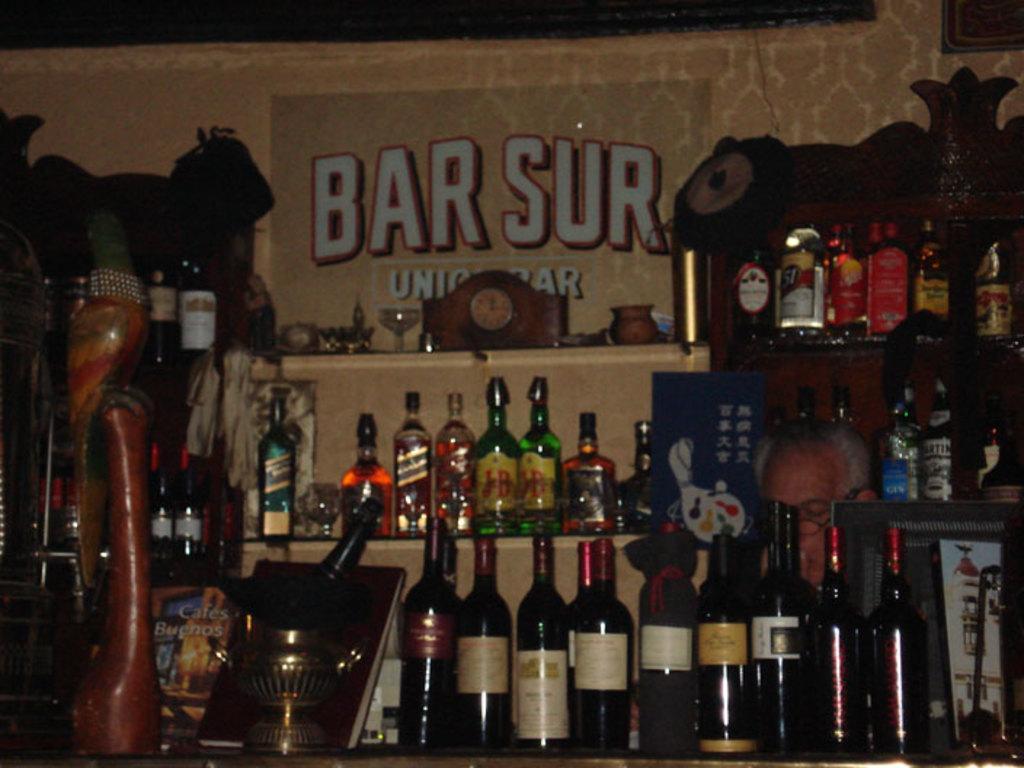What is the name of this bar?
Give a very brief answer. Bar sur. 